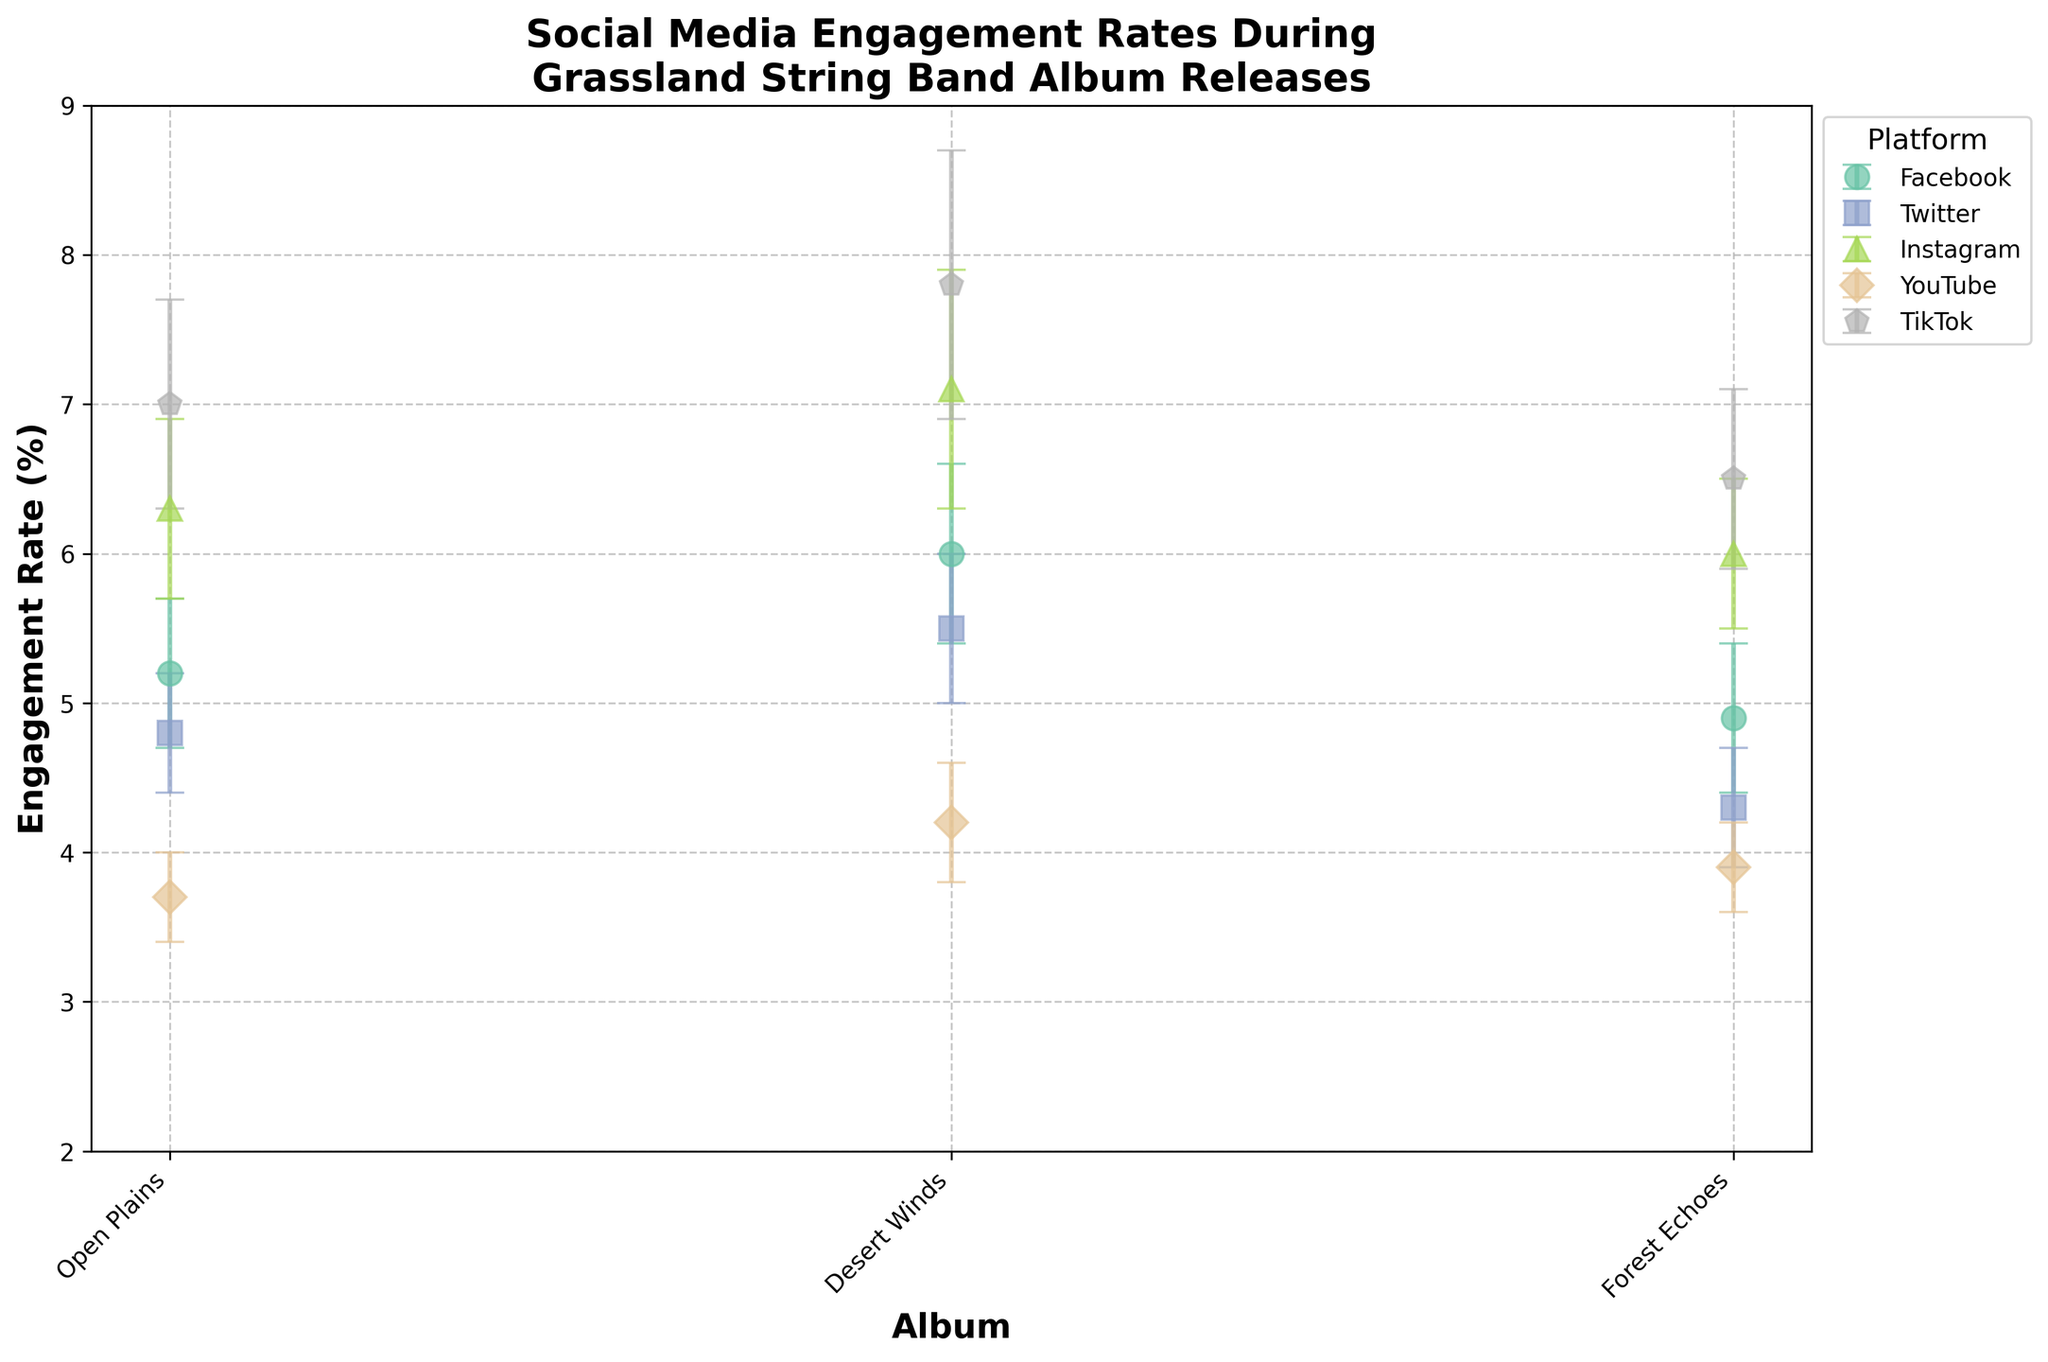What's the title of the figure? The title is located at the top of the figure and usually summarizes the dataset or insight being presented. It reads "Social Media Engagement Rates During Grassland String Band Album Releases."
Answer: Social Media Engagement Rates During Grassland String Band Album Releases What is the engagement rate of TikTok for the "Open Plains" album? Look for the TikTok data point corresponding to the "Open Plains" album on the x-axis and check the y-axis value, which is at 7.0%.
Answer: 7.0% Which platform has the highest engagement rate for the "Desert Winds" album? Identify all the data points for the "Desert Winds" album and compare their heights. TikTok is the highest with an engagement rate of 7.8%.
Answer: TikTok What is the range of engagement rates shown in the figure? Identify the lowest and highest engagement rates in the figure. YouTube for "Open Plains" has the lowest at 3.7%, and TikTok for "Desert Winds" has the highest at 7.8%. The range is 7.8 - 3.7.
Answer: 4.1% How does the engagement rate for Instagram change across the albums? Observe the Instagram data points for each album. They are 6.3% (Open Plains), 7.1% (Desert Winds), and 6.0% (Forest Echoes), indicating a peak for Desert Winds.
Answer: Peaks at Desert Winds Which platform shows the smallest error margin for any album, and for which album? Find the smallest error bars across all data points. YouTube for "Open Plains" has the smallest error bar at ±0.3%.
Answer: YouTube, Open Plains What is the difference in engagement rates between Facebook and Twitter for the "Forest Echoes" album? For "Forest Echoes," Facebook has 4.9% and Twitter has 4.3%. The difference is 4.9 - 4.3.
Answer: 0.6% Between "Open Plains" and "Desert Winds," which album had a higher engagement rate for Facebook, and by how much? Facebook's engagement rates are 5.2% for "Open Plains" and 6.0% for "Desert Winds." The difference is 6.0 - 5.2.
Answer: Desert Winds, 0.8% For which album did YouTube have the highest engagement rate? Identify YouTube's engagement rates for each album. "Desert Winds" has the highest at 4.2%.
Answer: Desert Winds What is the average engagement rate for Twitter across all albums? Sum Twitter's engagement rates for all albums and divide by the number of albums: (4.8 + 5.5 + 4.3)/3.
Answer: 4.87% 